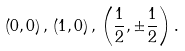<formula> <loc_0><loc_0><loc_500><loc_500>\left ( 0 , 0 \right ) , \, \left ( 1 , 0 \right ) , \, \left ( \frac { 1 } { 2 } , \pm \frac { 1 } { 2 } \right ) .</formula> 